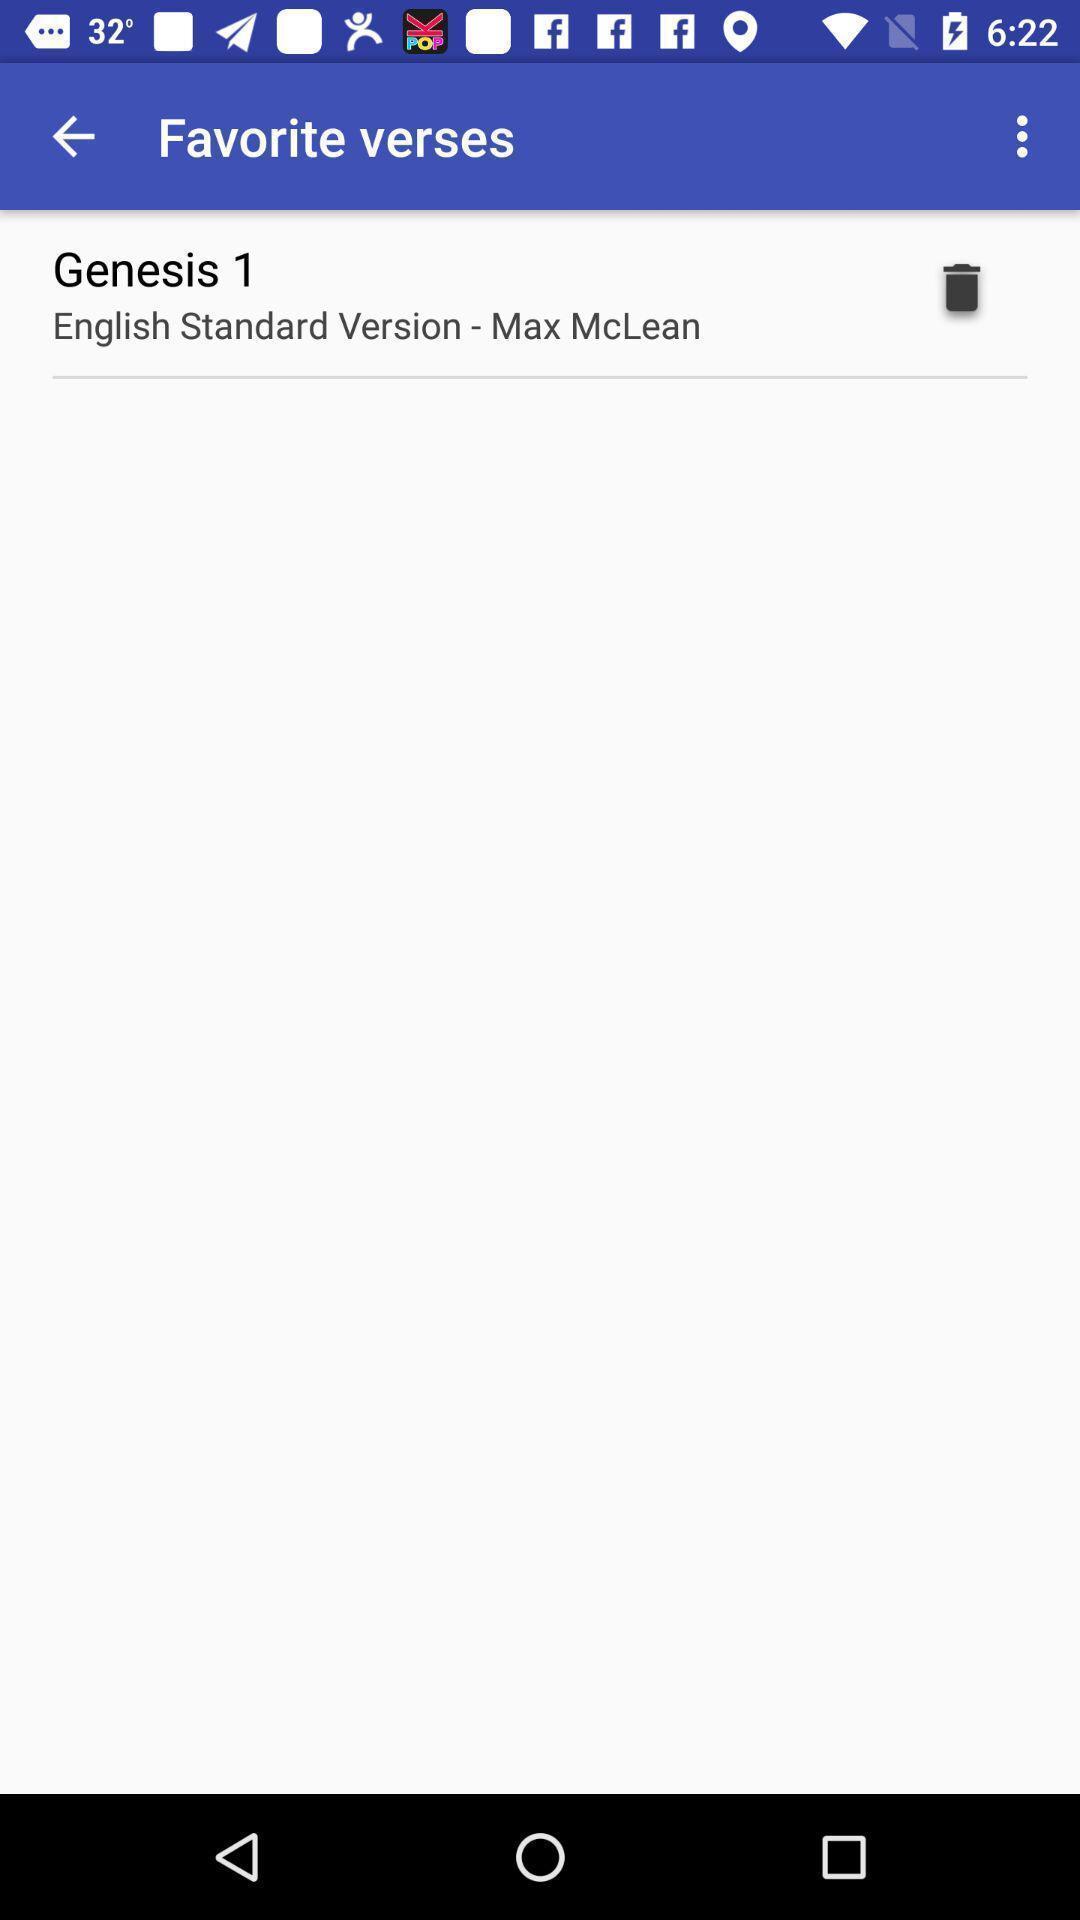Tell me what you see in this picture. Various verses displayed of an religious ebook app. 